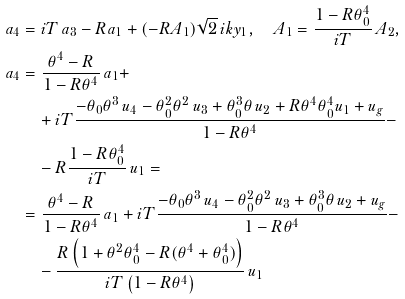Convert formula to latex. <formula><loc_0><loc_0><loc_500><loc_500>a _ { 4 } & = i T \, a _ { 3 } - R a _ { 1 } + ( - R A _ { 1 } ) \sqrt { 2 } \, i k y _ { 1 } , \quad A _ { 1 } = \frac { 1 - R \theta _ { 0 } ^ { 4 } } { i T } \, A _ { 2 } , \\ a _ { 4 } & = \frac { \theta ^ { 4 } - R } { 1 - R \theta ^ { 4 } } \, a _ { 1 } + \\ & \quad + i T \frac { - \theta _ { 0 } \theta ^ { 3 } \, u _ { 4 } - \theta _ { 0 } ^ { 2 } \theta ^ { 2 } \, u _ { 3 } + \theta _ { 0 } ^ { 3 } \theta \, u _ { 2 } + R \theta ^ { 4 } \theta _ { 0 } ^ { 4 } u _ { 1 } + u _ { g } } { 1 - R \theta ^ { 4 } } - \\ & \quad - R \frac { 1 - R \theta _ { 0 } ^ { 4 } } { i T } \, u _ { 1 } = \\ & = \frac { \theta ^ { 4 } - R } { 1 - R \theta ^ { 4 } } \, a _ { 1 } + i T \frac { - \theta _ { 0 } \theta ^ { 3 } \, u _ { 4 } - \theta _ { 0 } ^ { 2 } \theta ^ { 2 } \, u _ { 3 } + \theta _ { 0 } ^ { 3 } \theta \, u _ { 2 } + u _ { g } } { 1 - R \theta ^ { 4 } } - \\ & \quad - \frac { R \left ( 1 + \theta ^ { 2 } \theta _ { 0 } ^ { 4 } - R ( \theta ^ { 4 } + \theta _ { 0 } ^ { 4 } ) \right ) } { i T \left ( 1 - R \theta ^ { 4 } \right ) } \, u _ { 1 }</formula> 